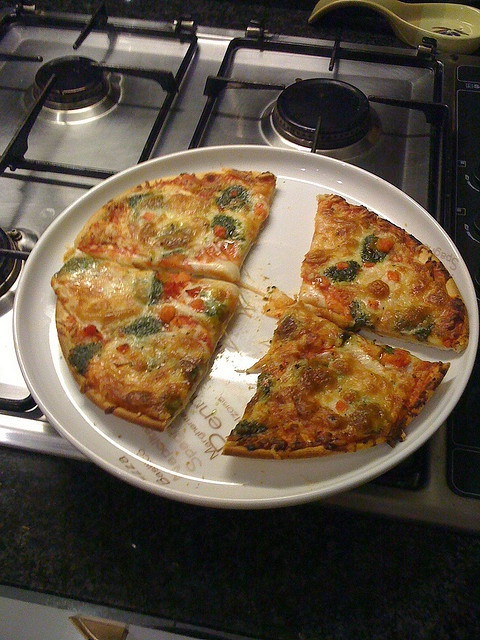Describe the objects in this image and their specific colors. I can see oven in black, olive, darkgray, gray, and tan tones, pizza in black, olive, and tan tones, pizza in black, olive, and maroon tones, and pizza in black, brown, maroon, tan, and olive tones in this image. 